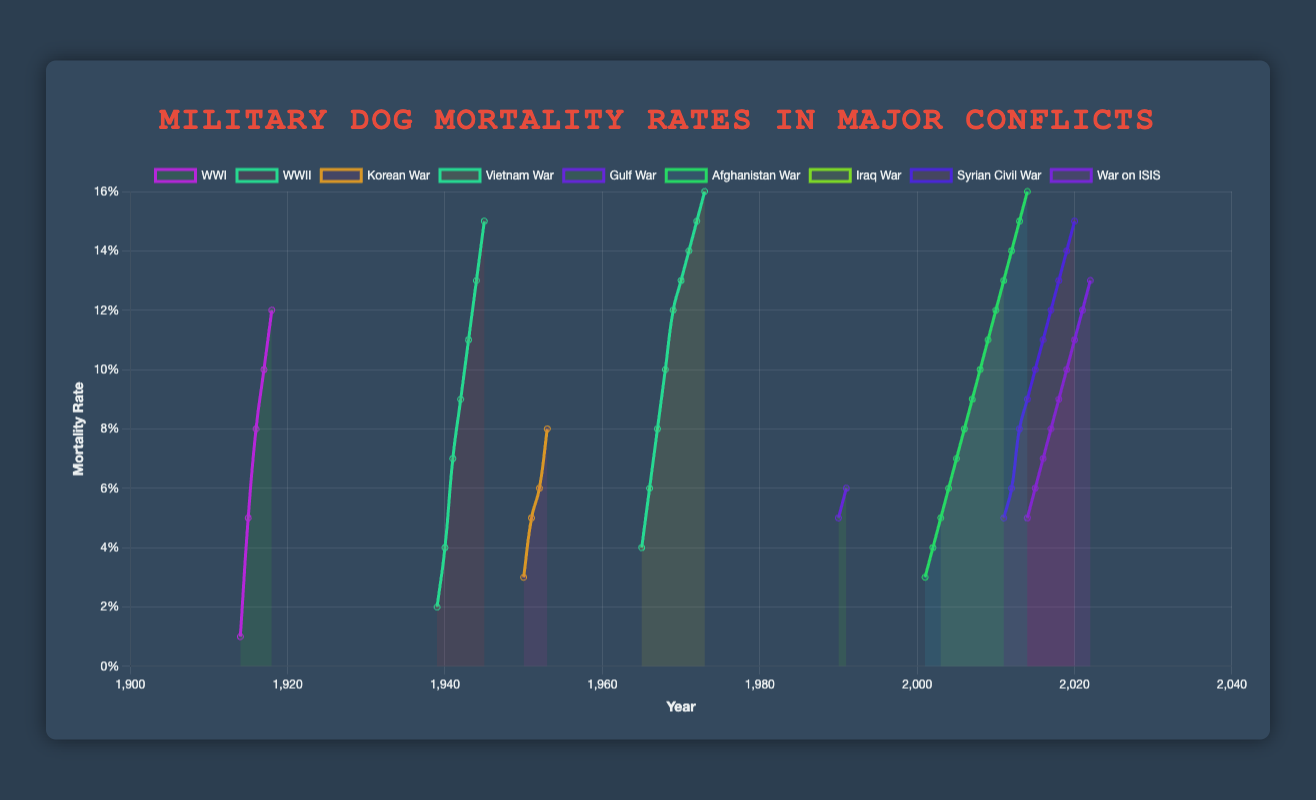What is the highest mortality rate among military dogs during World War II? The graph shows multiple data points for World War II from 1939 to 1945. The mortality rate starts at 0.02 in 1939 and increases over time. The highest mortality rate observed for World War II is in 1945, which is 0.15.
Answer: 0.15 How does the mortality rate in the first year of the Vietnam War compare to the first year of the Korean War? To compare the mortality rates, we need to observe the first year of each war. For the Vietnam War, the first year is 1965 with a mortality rate of 0.04. For the Korean War, it is 1950 with a mortality rate of 0.03. Therefore, the mortality rate in the first year of the Vietnam War is higher than in the first year of the Korean War.
Answer: 0.04 vs 0.03 What is the average mortality rate of military dogs during the Gulf War? The Gulf War spans the years 1990 and 1991 with mortality rates of 0.05 and 0.06, respectively. The average is calculated by summing these rates and dividing by the number of years: (0.05 + 0.06) / 2 = 0.055.
Answer: 0.055 Which conflict shows the most significant increase in mortality rate within its first 3 years, the Afghanistan War or the Iraq War? To assess the increase, we compare the rates over the initial 3 years of each war. The Afghanistan War from 2001 to 2003 shows values from 0.03 to 0.05—an increase of 0.02. The Iraq War from 2003 to 2005 shows values from 0.05 to 0.07—an increase of 0.02. Both wars show the same increase within the first 3 years.
Answer: Same increase What is the median mortality rate of military dogs during World War I? To find the median, we need to list the mortality rates for World War I (0.01, 0.05, 0.08, 0.10, 0.12) and find the middle value. The median of this sorted list is 0.08.
Answer: 0.08 For which war did the mortality rate first reach 0.10? In evaluating each conflict’s data, we find that World War I reached a mortality rate of 0.10 in 1917, and no other war reached 0.10 before this year.
Answer: World War I Comparing the trends, which conflict showed the most consistent annual increase in the mortality rate? A consistent increase means the rate rises steadily by the same margin. The Vietnam War shows a steady increase of 0.02 every year from 1965 to 1967, and afterward, the increments remain similar but vary slightly. Therefore, the Vietnam War shows a fairly consistent yearly increase.
Answer: Vietnam War Which conflict had the lowest mortality rate in the last documented year on the plot? The last documented years and their respective mortality rates for each conflict on the graph are as follows: - World War I: 1918, 0.12 - World War II: 1945, 0.15 - Korean War: 1953, 0.08 - Vietnam War: 1973, 0.16 - Gulf War: 1991, 0.06 - Afghanistan War: 2014, 0.16 - Iraq War: 2011, 0.13 - Syrian Civil War: 2020, 0.15 - War on ISIS: 2022, 0.13 The Korean War in 1953 has the lowest at 0.08.
Answer: Korean War Among the conflict periods, which had a sudden spike in the mortality rate after the first couple of years? The visual data indicates World War II experienced a notable spike in mortality rates between 1940 (0.04) and 1941 (0.07).
Answer: World War II What is the trend in the mortality rate of military dogs during the War on ISIS from 2014 to 2022? Observing the data from 2014 to 2022 shows an increasing trend in the mortality rate every year: starting at 0.05 in 2014 and ending at 0.13 in 2022. This indicates a steady rise over the period.
Answer: Increasing trend 